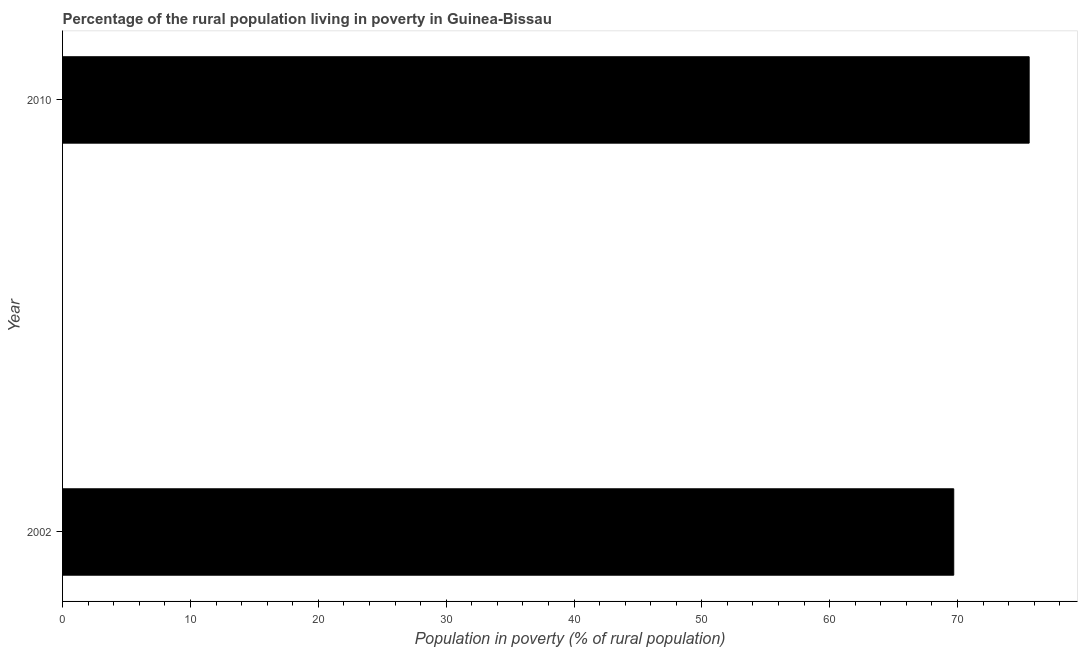What is the title of the graph?
Ensure brevity in your answer.  Percentage of the rural population living in poverty in Guinea-Bissau. What is the label or title of the X-axis?
Offer a very short reply. Population in poverty (% of rural population). What is the label or title of the Y-axis?
Give a very brief answer. Year. What is the percentage of rural population living below poverty line in 2010?
Keep it short and to the point. 75.6. Across all years, what is the maximum percentage of rural population living below poverty line?
Your answer should be compact. 75.6. Across all years, what is the minimum percentage of rural population living below poverty line?
Make the answer very short. 69.7. In which year was the percentage of rural population living below poverty line maximum?
Make the answer very short. 2010. What is the sum of the percentage of rural population living below poverty line?
Give a very brief answer. 145.3. What is the average percentage of rural population living below poverty line per year?
Your answer should be very brief. 72.65. What is the median percentage of rural population living below poverty line?
Give a very brief answer. 72.65. In how many years, is the percentage of rural population living below poverty line greater than 42 %?
Offer a terse response. 2. Do a majority of the years between 2002 and 2010 (inclusive) have percentage of rural population living below poverty line greater than 56 %?
Ensure brevity in your answer.  Yes. What is the ratio of the percentage of rural population living below poverty line in 2002 to that in 2010?
Make the answer very short. 0.92. Are all the bars in the graph horizontal?
Make the answer very short. Yes. What is the difference between two consecutive major ticks on the X-axis?
Ensure brevity in your answer.  10. What is the Population in poverty (% of rural population) of 2002?
Provide a succinct answer. 69.7. What is the Population in poverty (% of rural population) in 2010?
Offer a very short reply. 75.6. What is the difference between the Population in poverty (% of rural population) in 2002 and 2010?
Ensure brevity in your answer.  -5.9. What is the ratio of the Population in poverty (% of rural population) in 2002 to that in 2010?
Provide a short and direct response. 0.92. 